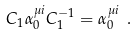<formula> <loc_0><loc_0><loc_500><loc_500>C _ { 1 } \alpha _ { 0 } ^ { \mu i } C _ { 1 } ^ { - 1 } = \alpha _ { 0 } ^ { \mu i } \ .</formula> 